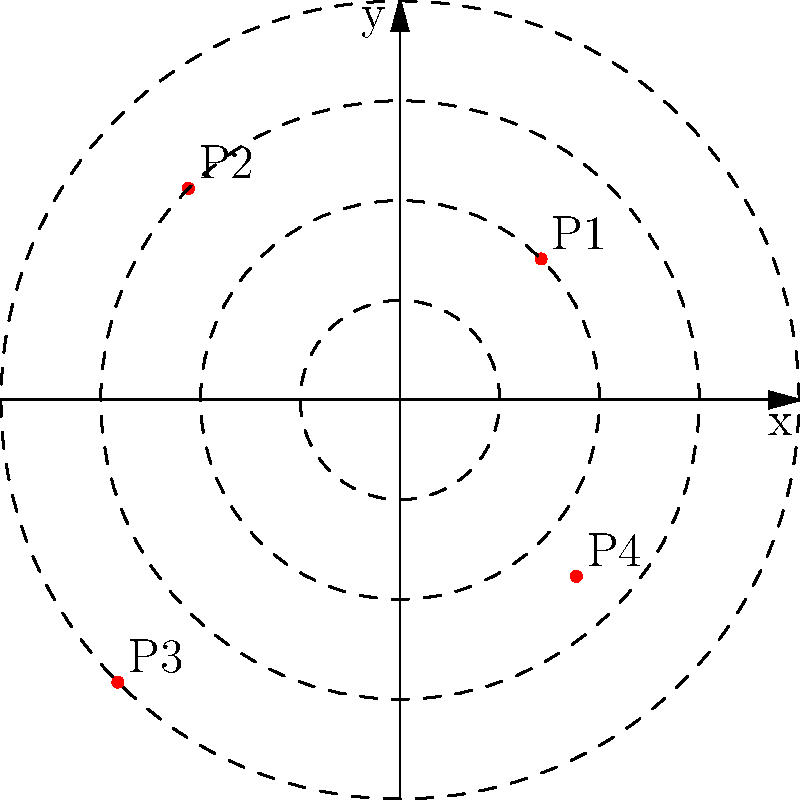In an ancient encryption system, a secret message is encoded using polar coordinates. Four key points are used: $P_1(2, \frac{\pi}{4})$, $P_2(3, \frac{3\pi}{4})$, $P_3(4, \frac{5\pi}{4})$, and $P_4(2.5, \frac{7\pi}{4})$. To decode the message, you need to apply a transformation that rotates each point by $\frac{\pi}{2}$ counterclockwise and doubles its distance from the origin. What are the polar coordinates of the transformed $P_2$? Let's approach this step-by-step:

1) The original coordinates of $P_2$ are $(3, \frac{3\pi}{4})$.

2) The transformation involves two steps:
   a) Rotating by $\frac{\pi}{2}$ counterclockwise
   b) Doubling the distance from the origin

3) For the rotation:
   - The new angle will be $\frac{3\pi}{4} + \frac{\pi}{2} = \frac{5\pi}{4}$

4) For doubling the distance:
   - The new radius will be $3 \times 2 = 6$

5) Therefore, the new coordinates of $P_2$ after transformation are $(6, \frac{5\pi}{4})$

This transformation effectively moves the point to a new position that's rotated 90° counterclockwise and twice as far from the origin.
Answer: $(6, \frac{5\pi}{4})$ 